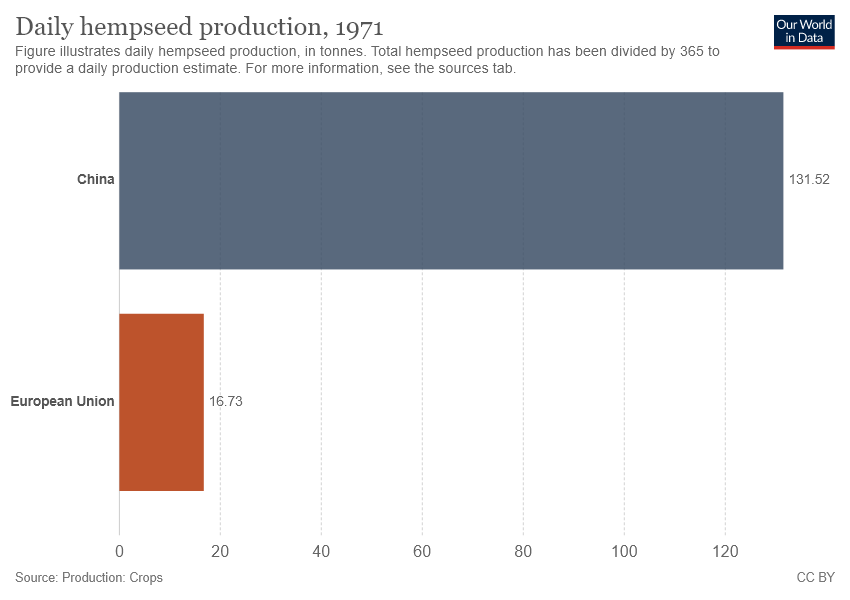Give some essential details in this illustration. China has the highest daily production of hempseed. The value of China is greater than that of the European Union. 